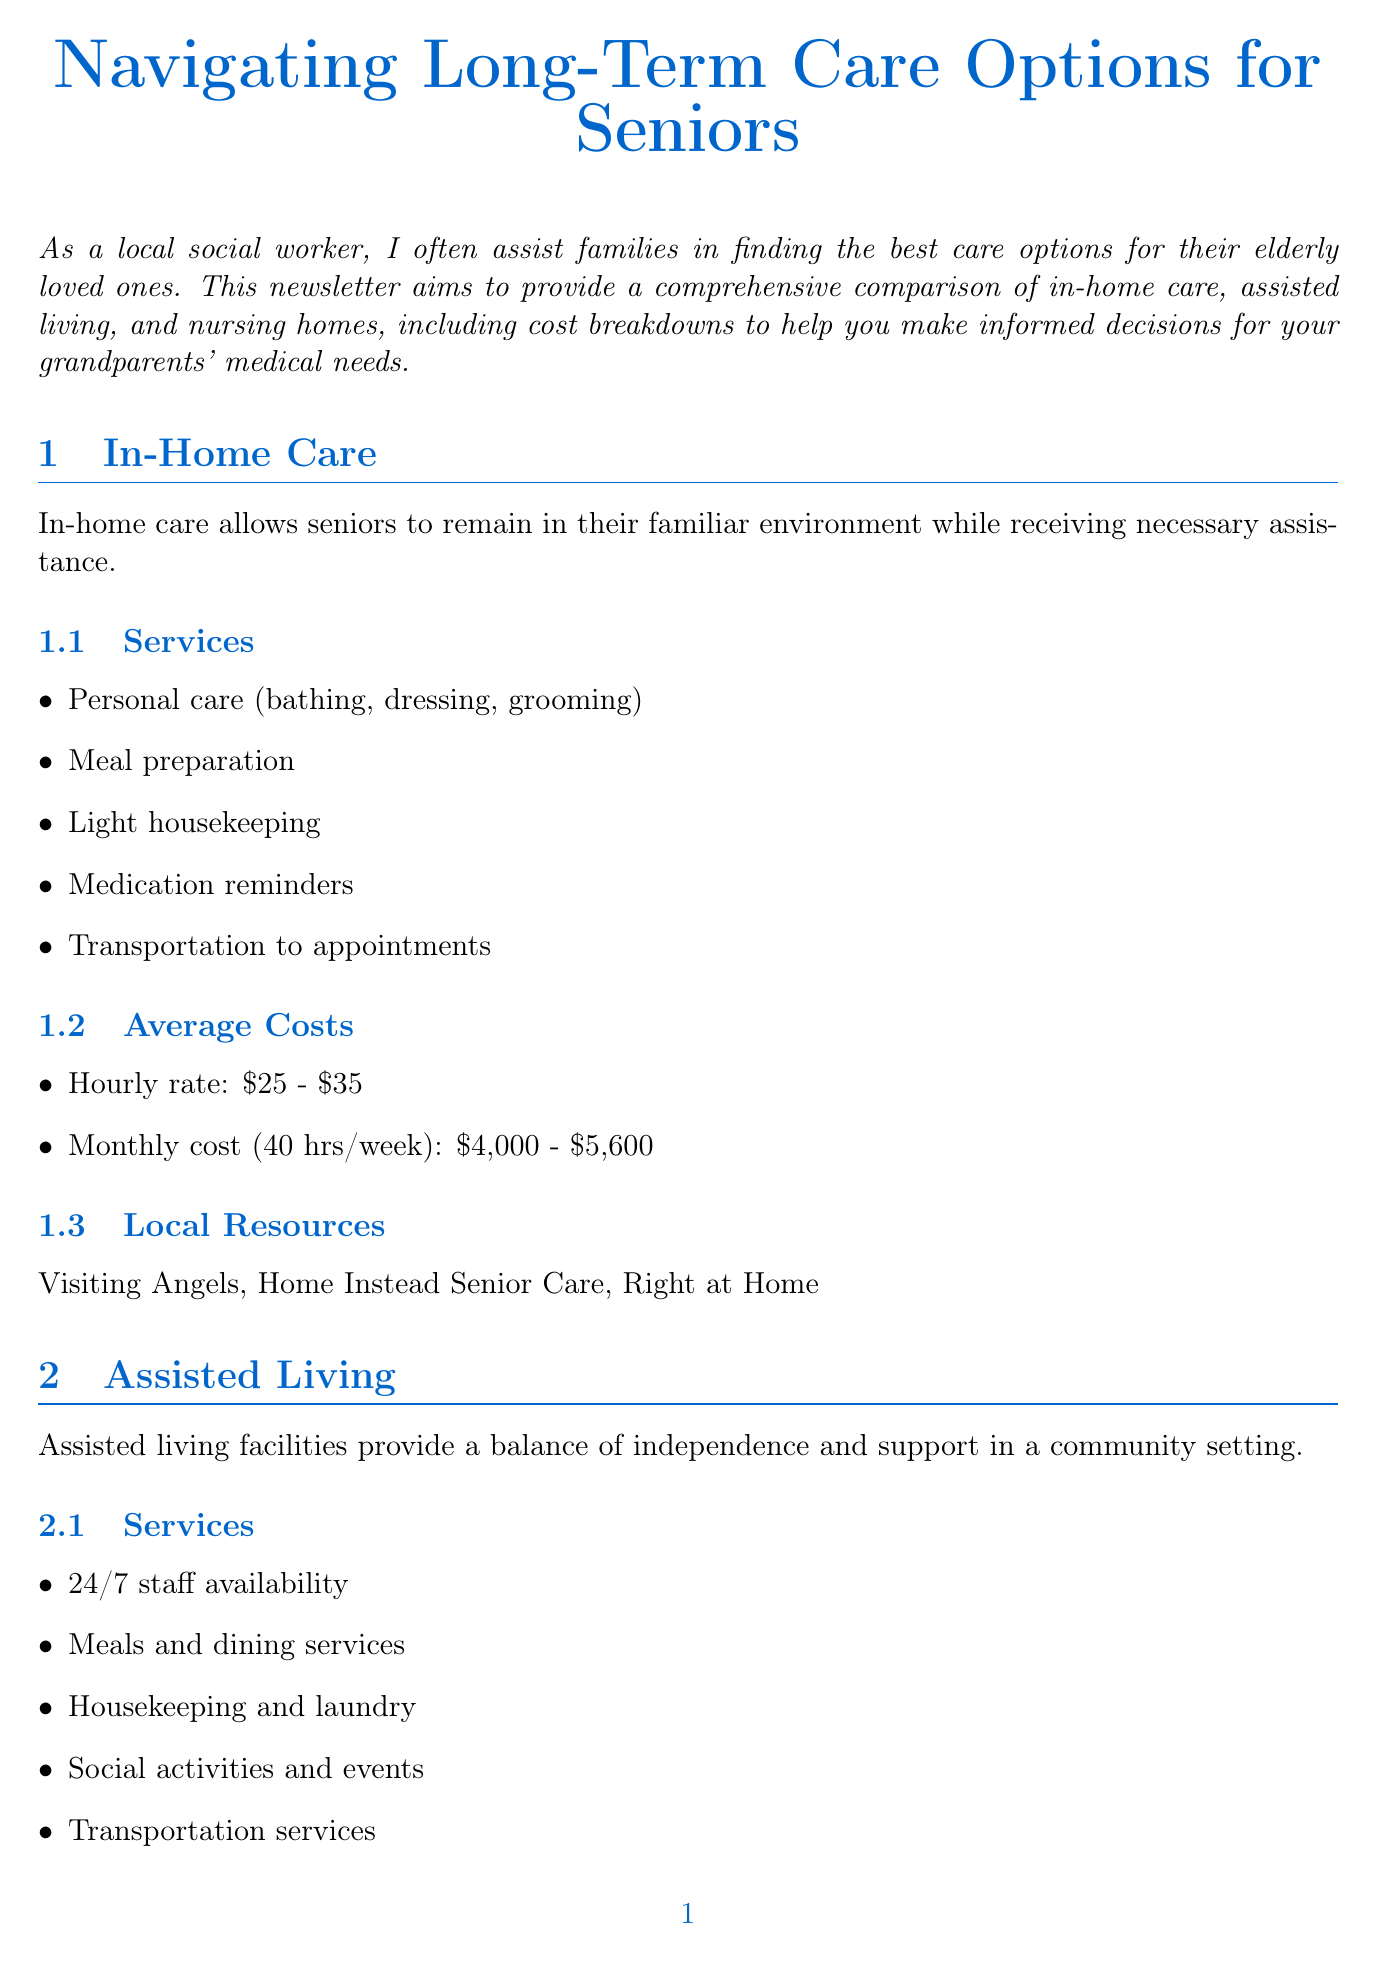What services are included in in-home care? In-home care services listed in the document include personal care, meal preparation, light housekeeping, medication reminders, and transportation to appointments.
Answer: Personal care, meal preparation, light housekeeping, medication reminders, transportation to appointments What is the monthly cost range for assisted living? The document states that the average monthly cost for assisted living ranges from $3,500 to $6,000.
Answer: $3,500 - $6,000 What type of care do nursing homes provide? Nursing homes provide round-the-clock skilled nursing care for seniors with complex medical needs.
Answer: Round-the-clock skilled nursing care Which local facility is listed for assisted living? Among the facilities listed for assisted living, Atria Senior Living is included.
Answer: Atria Senior Living What is the daily rate for nursing homes? The document specifies that the average daily rate for nursing homes is between $250 and $350.
Answer: $250 - $350 How does Medicaid assist with long-term care? Medicaid covers long-term care for eligible low-income seniors, as stated in the financial assistance options section.
Answer: Covers long-term care for eligible low-income seniors What organization provides free health insurance counseling? The SHINE program provides free health insurance counseling according to the local resources section.
Answer: SHINE Program Which service is offered by the Area Agency on Aging? The Area Agency on Aging offers information and referral services as one of its services.
Answer: Information and referral 